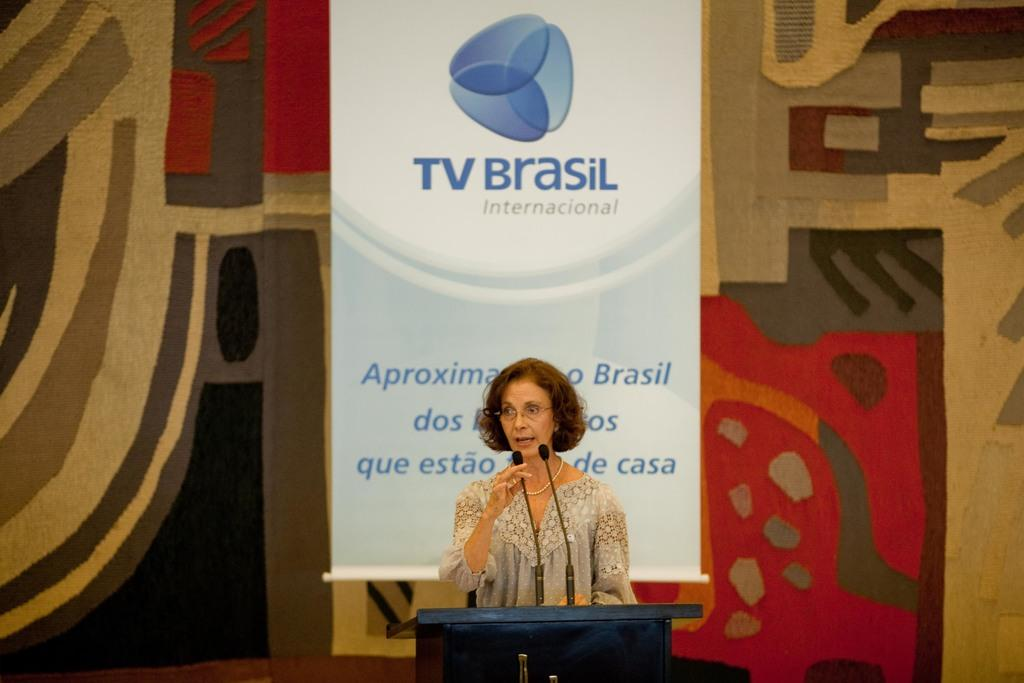Provide a one-sentence caption for the provided image. A woman stands at a podium with a TV Brasil banner in the background. 